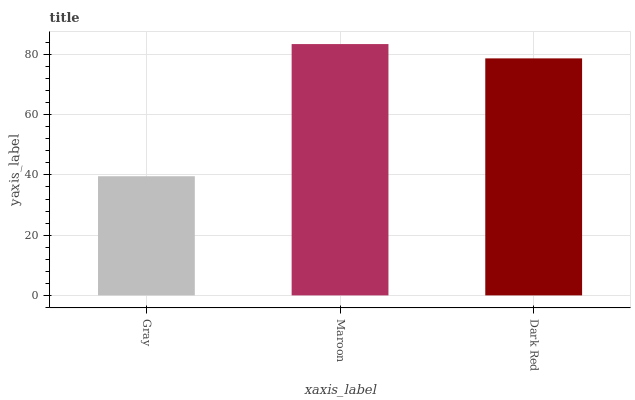Is Gray the minimum?
Answer yes or no. Yes. Is Maroon the maximum?
Answer yes or no. Yes. Is Dark Red the minimum?
Answer yes or no. No. Is Dark Red the maximum?
Answer yes or no. No. Is Maroon greater than Dark Red?
Answer yes or no. Yes. Is Dark Red less than Maroon?
Answer yes or no. Yes. Is Dark Red greater than Maroon?
Answer yes or no. No. Is Maroon less than Dark Red?
Answer yes or no. No. Is Dark Red the high median?
Answer yes or no. Yes. Is Dark Red the low median?
Answer yes or no. Yes. Is Gray the high median?
Answer yes or no. No. Is Maroon the low median?
Answer yes or no. No. 